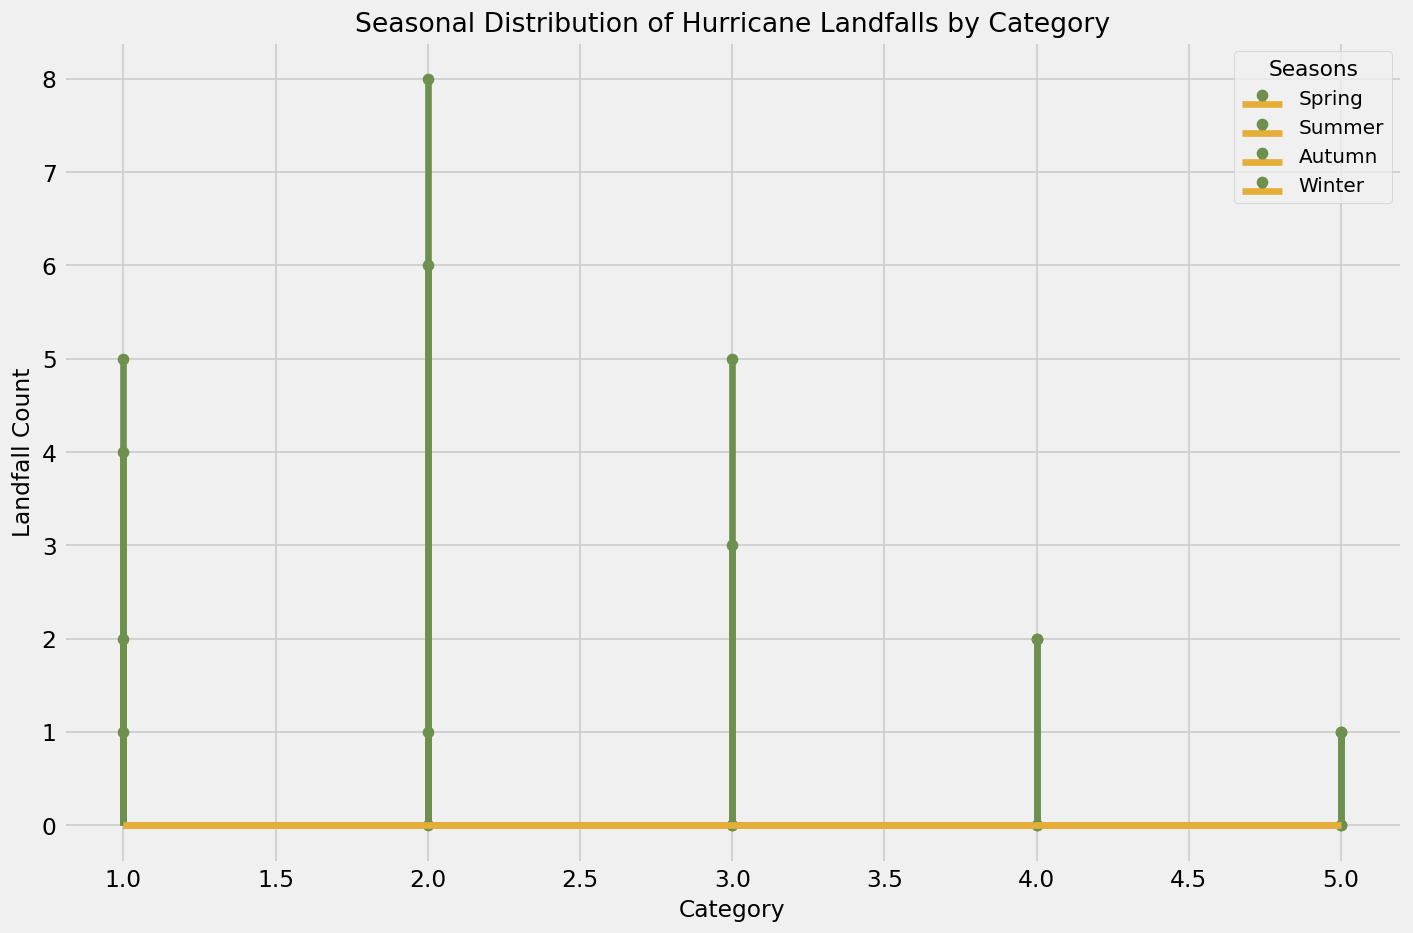Which season has the highest number of category 2 hurricane landfalls? Observing the stem plots, we see that summer has the highest number of category 2 landfalls, with 8 occurrences.
Answer: Summer How many total hurricane landfalls occurred in the Spring season? Add the landfall counts for all categories in Spring: 2 + 1 + 0 + 0 + 0 = 3
Answer: 3 Compare the number of hurricane landfalls in Summer and Winter for category 1. In Summer, category 1 has 5 landfalls. In Winter, category 1 has 1 landfall. So, Summer has more.
Answer: Summer Which season has no category 3 hurricane landfalls? Observing category 3 plots: Spring and Winter both have zero landfall counts for category 3 hurricanes.
Answer: Spring and Winter How does the number of category 5 landfalls in Autumn compare with those in Summer? Both Autumn and Summer have 1 category 5 landfall each, so they are equal.
Answer: Equal During which seasons do zero landfalls occur for categories 4 and 5 simultaneously? Looking at the data for categories 4 and 5:
- Spring: 0 + 0 = 0
- Winter:  0 + 0 = 0
Both Spring and Winter have zero landfalls for these categories.
Answer: Spring and Winter 